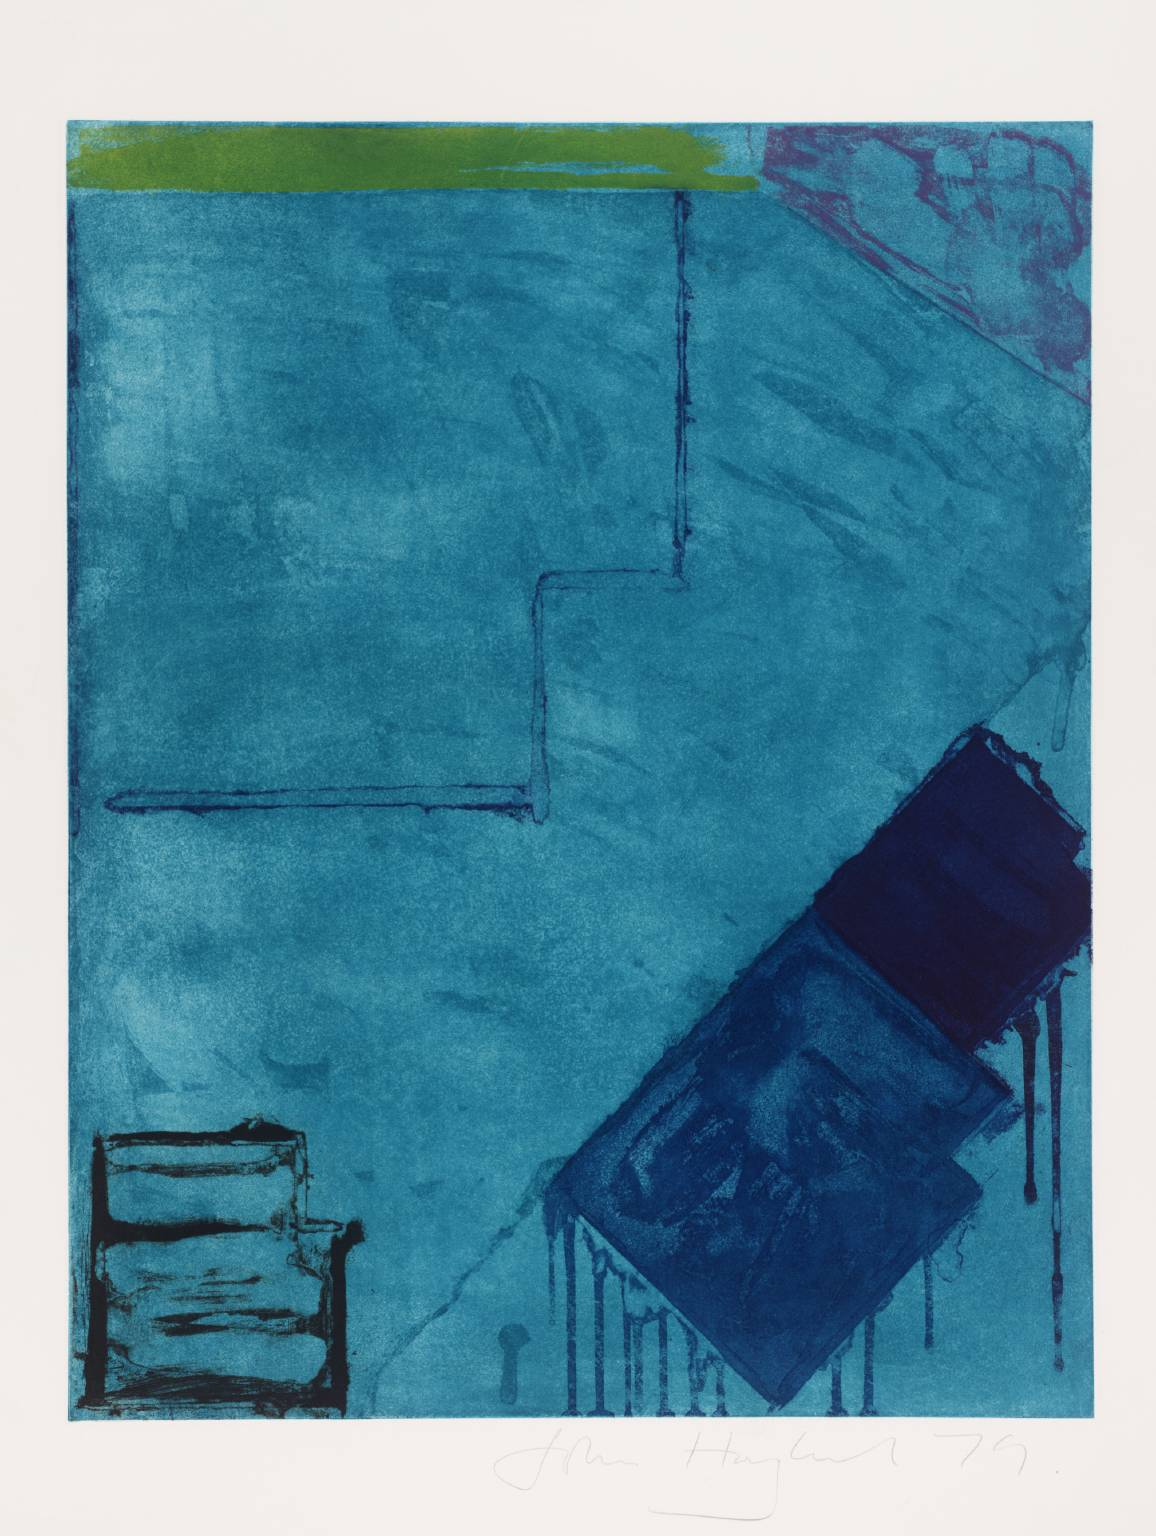What does this image evoke for you on an emotional level? The image, with its vast expanses of blue, conveys a serene and contemplative atmosphere, which may invoke feelings of introspection and tranquility in the viewer. However, the contrast provided by the green and red elements could introduce tones of hope or passion. The combination of these aspects might stir a mixed emotional response, prompting reflection on the interplay of calm and vitality within one's inner landscape. 